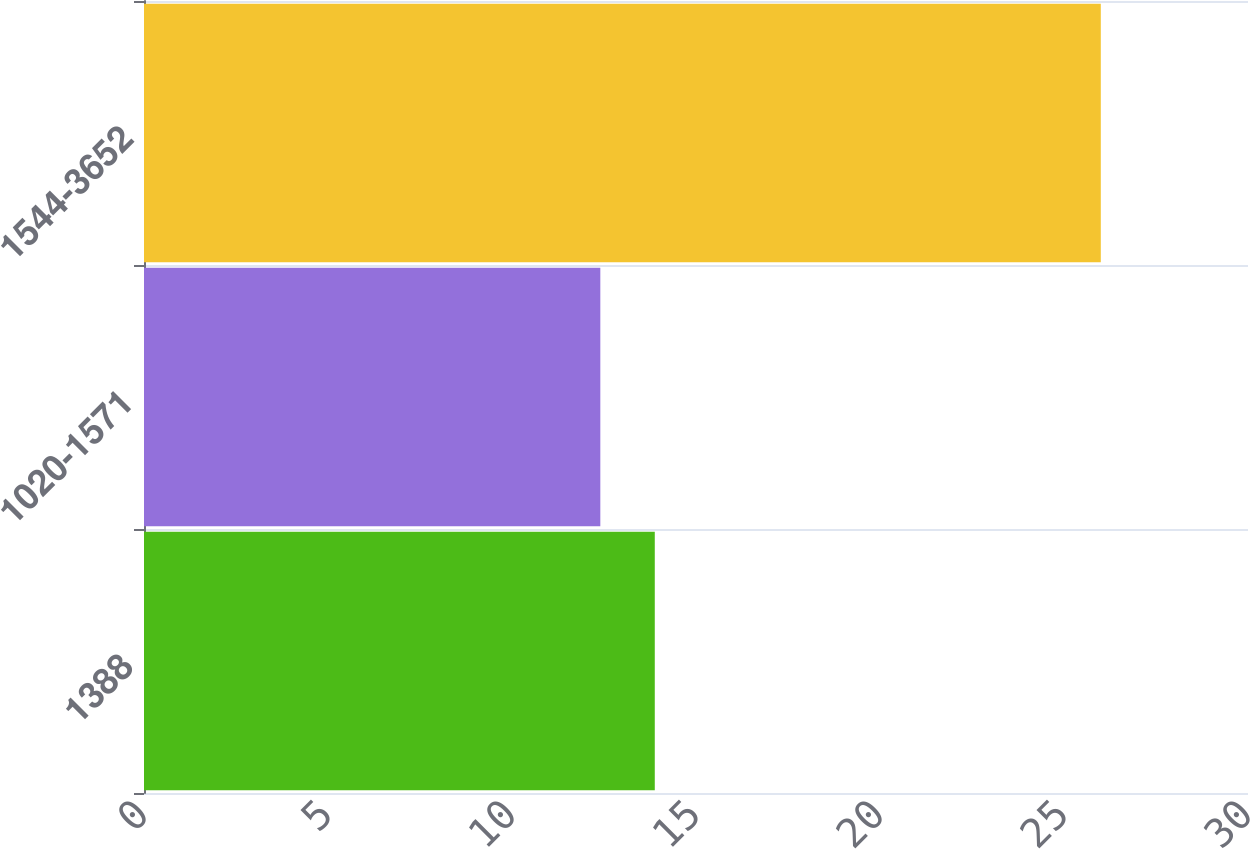Convert chart to OTSL. <chart><loc_0><loc_0><loc_500><loc_500><bar_chart><fcel>1388<fcel>1020-1571<fcel>1544-3652<nl><fcel>13.88<fcel>12.4<fcel>26<nl></chart> 